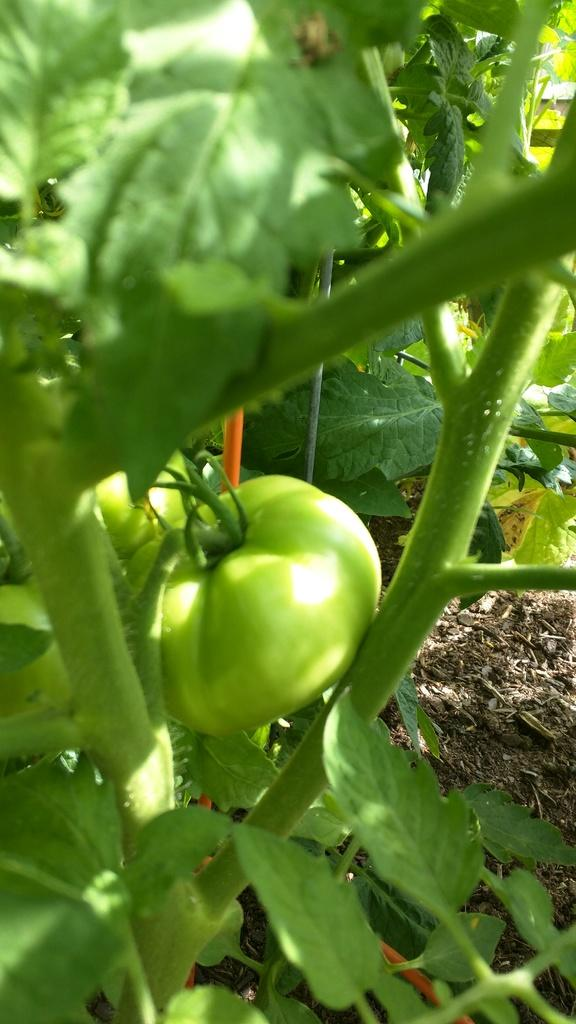What type of fruit is present in the image? There is a green color tomato in the image. What parts of the tomato plant can be seen in the image? There are stems and leaves in the image. What does the sister of the tomato need to do in order to clear her throat? There is no reference to a sister or throat in the image, so it is not possible to answer that question. 